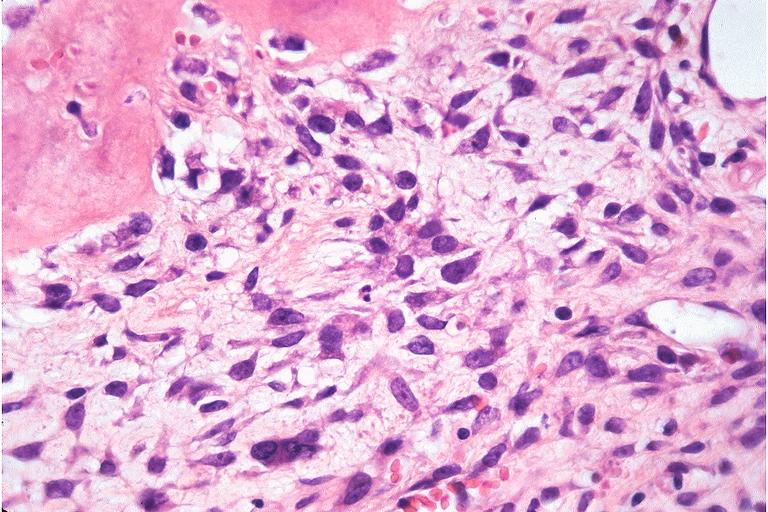does hand show osteosarcoma?
Answer the question using a single word or phrase. No 